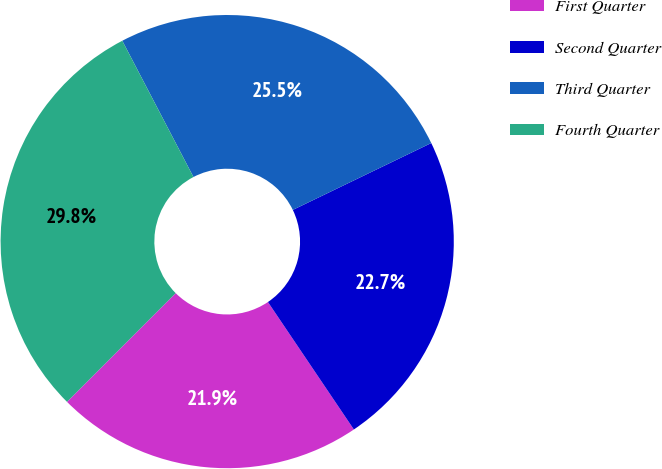Convert chart to OTSL. <chart><loc_0><loc_0><loc_500><loc_500><pie_chart><fcel>First Quarter<fcel>Second Quarter<fcel>Third Quarter<fcel>Fourth Quarter<nl><fcel>21.94%<fcel>22.72%<fcel>25.5%<fcel>29.84%<nl></chart> 